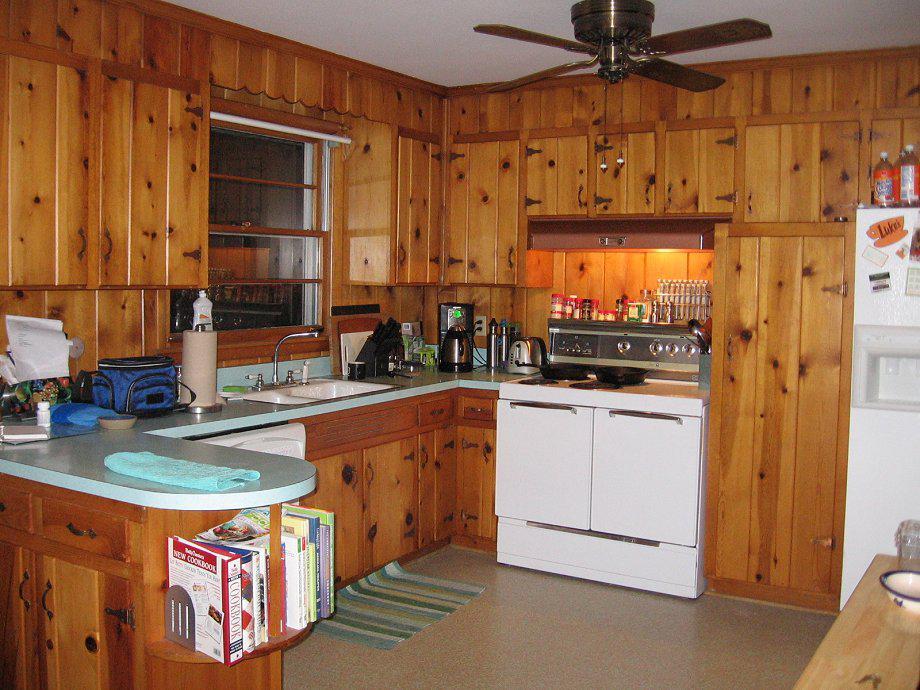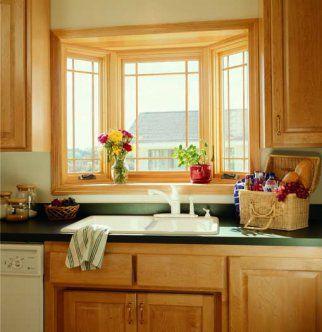The first image is the image on the left, the second image is the image on the right. Given the left and right images, does the statement "In one image, a double sink with goose neck faucet is in front of a white three-bay window that has equal size window panes." hold true? Answer yes or no. No. The first image is the image on the left, the second image is the image on the right. Considering the images on both sides, is "Right image shows a bay window over a double sink in a white kitchen." valid? Answer yes or no. No. 